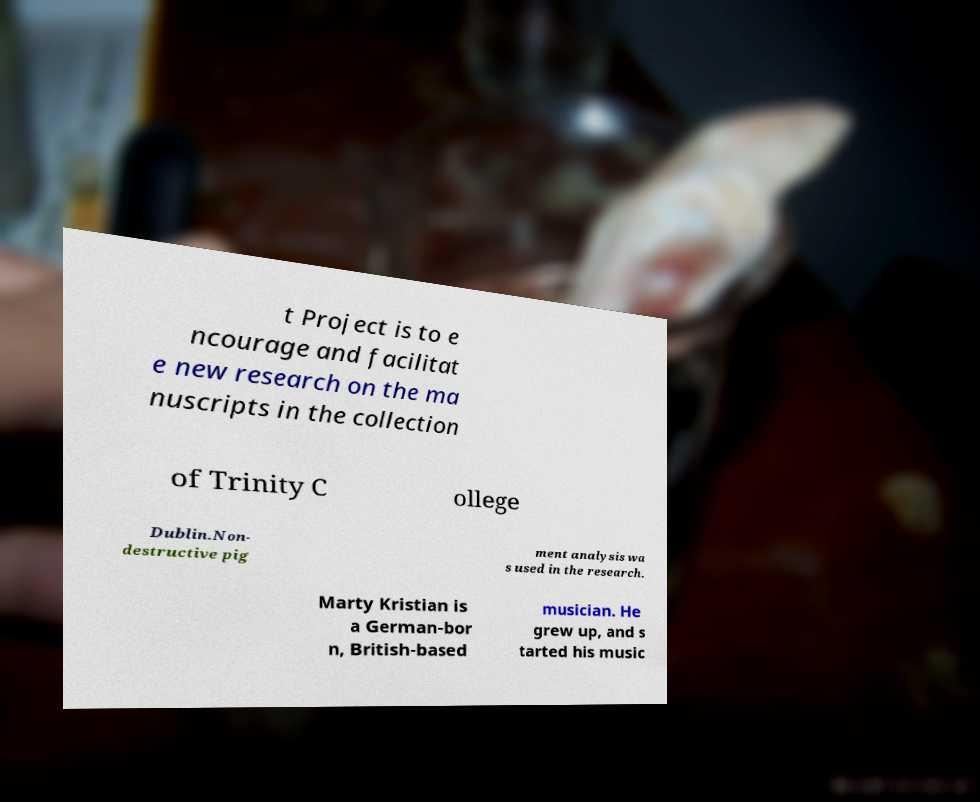For documentation purposes, I need the text within this image transcribed. Could you provide that? t Project is to e ncourage and facilitat e new research on the ma nuscripts in the collection of Trinity C ollege Dublin.Non- destructive pig ment analysis wa s used in the research. Marty Kristian is a German-bor n, British-based musician. He grew up, and s tarted his music 